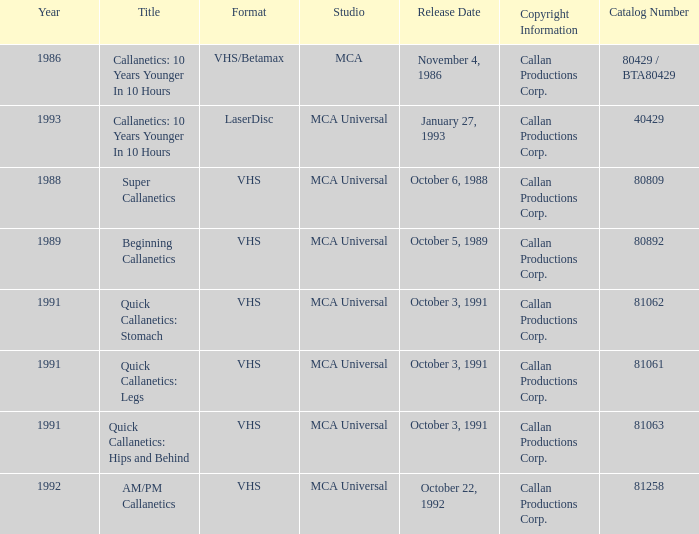What is the catalog number for october 6, 1988? 80809.0. 